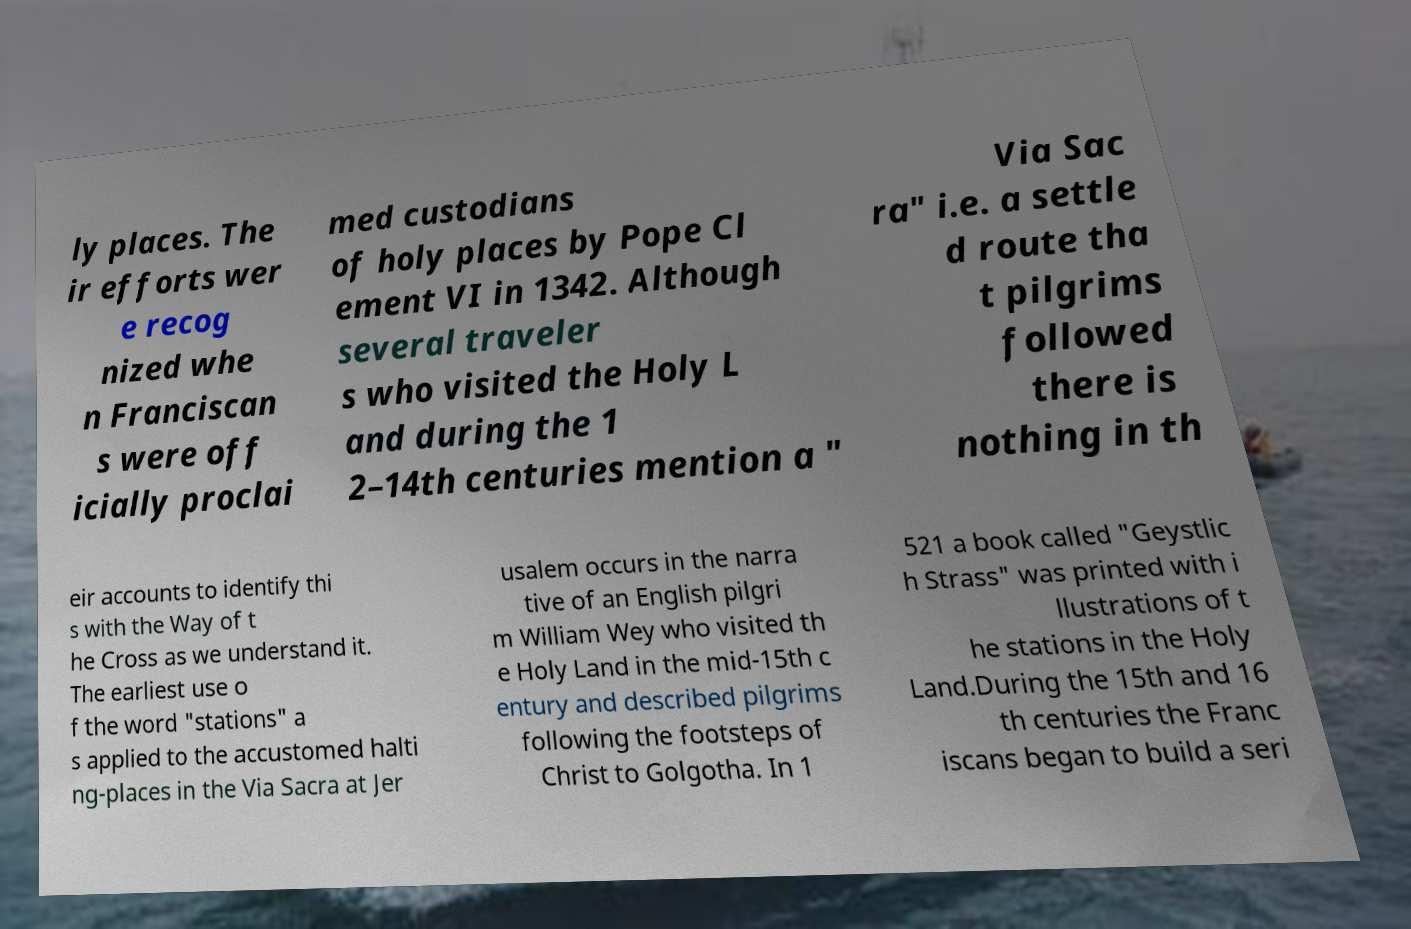There's text embedded in this image that I need extracted. Can you transcribe it verbatim? ly places. The ir efforts wer e recog nized whe n Franciscan s were off icially proclai med custodians of holy places by Pope Cl ement VI in 1342. Although several traveler s who visited the Holy L and during the 1 2–14th centuries mention a " Via Sac ra" i.e. a settle d route tha t pilgrims followed there is nothing in th eir accounts to identify thi s with the Way of t he Cross as we understand it. The earliest use o f the word "stations" a s applied to the accustomed halti ng-places in the Via Sacra at Jer usalem occurs in the narra tive of an English pilgri m William Wey who visited th e Holy Land in the mid-15th c entury and described pilgrims following the footsteps of Christ to Golgotha. In 1 521 a book called "Geystlic h Strass" was printed with i llustrations of t he stations in the Holy Land.During the 15th and 16 th centuries the Franc iscans began to build a seri 